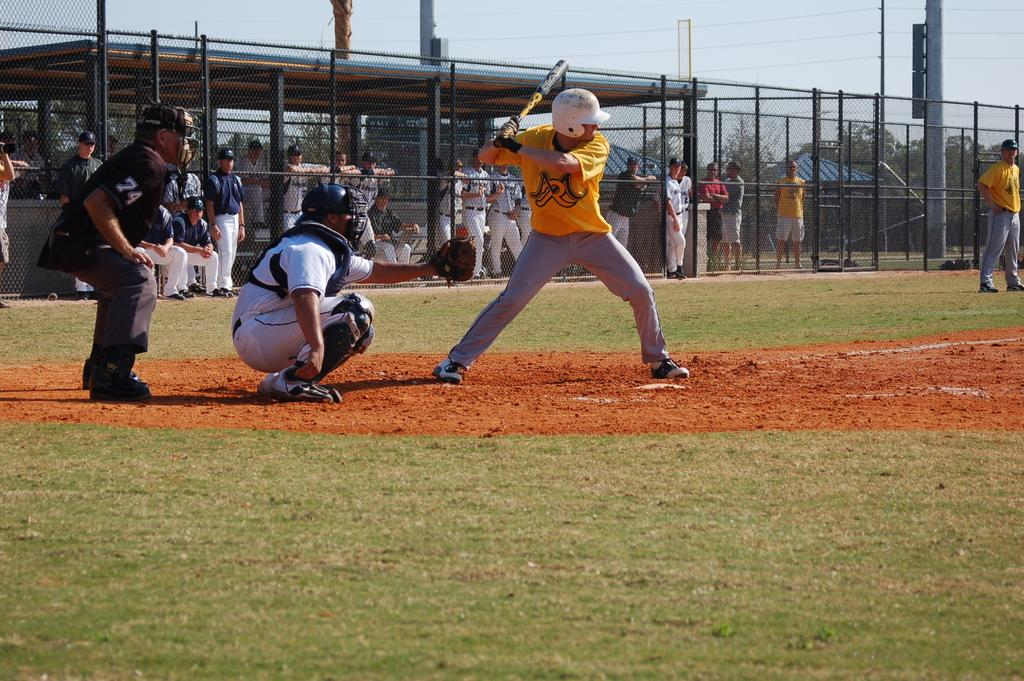<image>
Describe the image concisely. a person in yellow and an umpire with 74 on his sleeve 